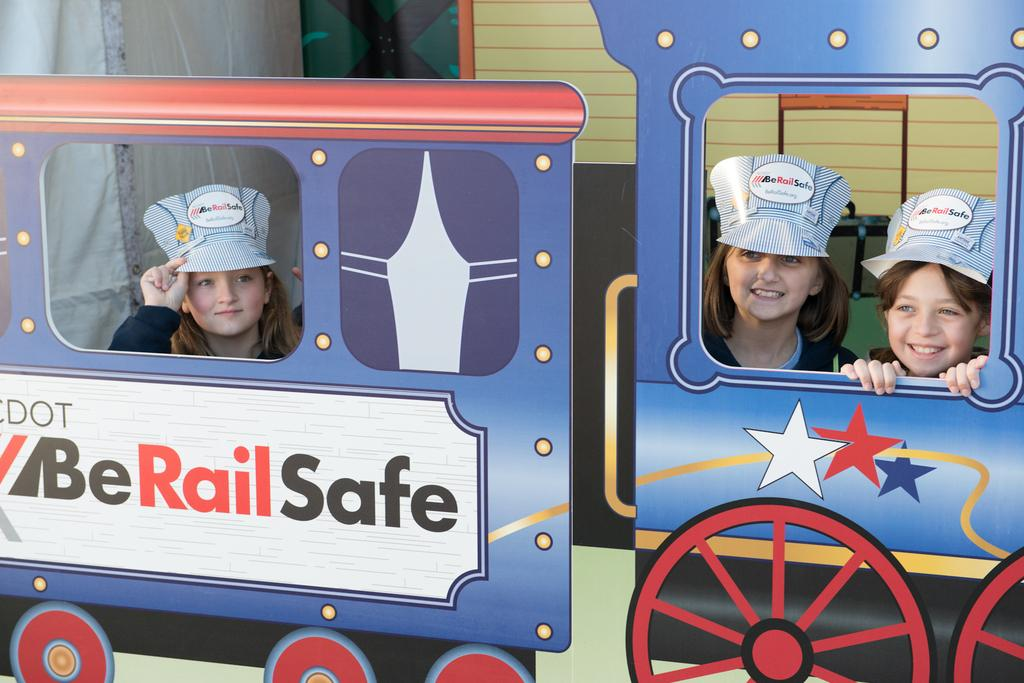What is the main subject of the image? The main subject of the image is people standing behind an object shaped like a train. What can be seen on the train-shaped object? There is text on the train-shaped object. What is visible in the background of the image? There is a wall in the background of the image. How does the wind affect the control of the train in the image? There is no train present in the image, only a train-shaped object. Additionally, the image does not depict any wind or its effects on the object. 